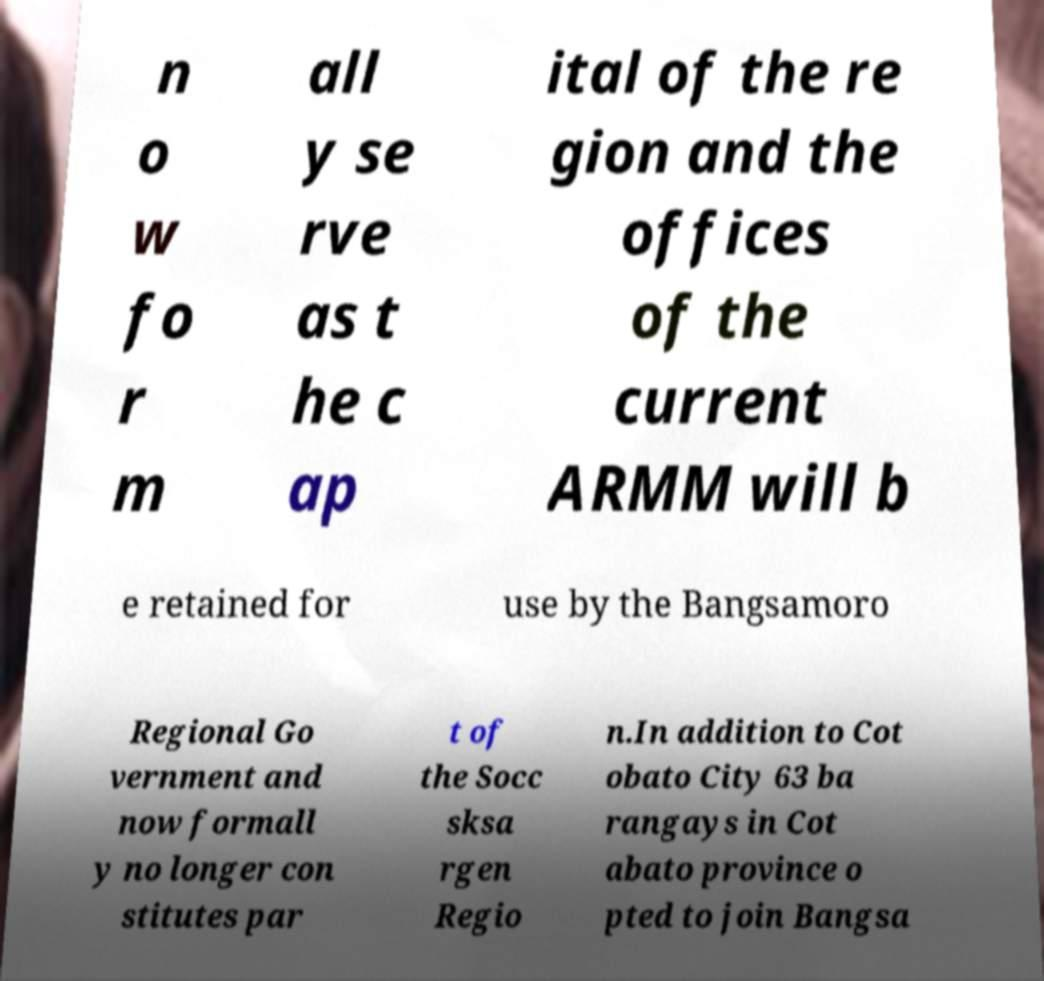Could you assist in decoding the text presented in this image and type it out clearly? n o w fo r m all y se rve as t he c ap ital of the re gion and the offices of the current ARMM will b e retained for use by the Bangsamoro Regional Go vernment and now formall y no longer con stitutes par t of the Socc sksa rgen Regio n.In addition to Cot obato City 63 ba rangays in Cot abato province o pted to join Bangsa 